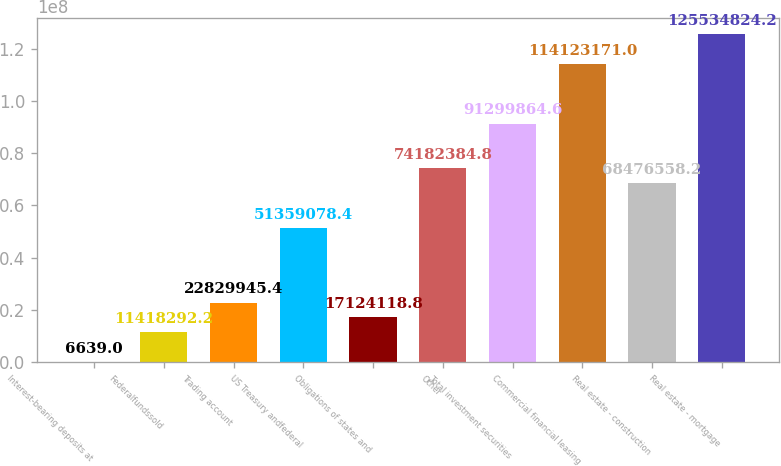Convert chart to OTSL. <chart><loc_0><loc_0><loc_500><loc_500><bar_chart><fcel>Interest-bearing deposits at<fcel>Federalfundssold<fcel>Trading account<fcel>US Treasury andfederal<fcel>Obligations of states and<fcel>Other<fcel>Total investment securities<fcel>Commercial financial leasing<fcel>Real estate - construction<fcel>Real estate - mortgage<nl><fcel>6639<fcel>1.14183e+07<fcel>2.28299e+07<fcel>5.13591e+07<fcel>1.71241e+07<fcel>7.41824e+07<fcel>9.12999e+07<fcel>1.14123e+08<fcel>6.84766e+07<fcel>1.25535e+08<nl></chart> 